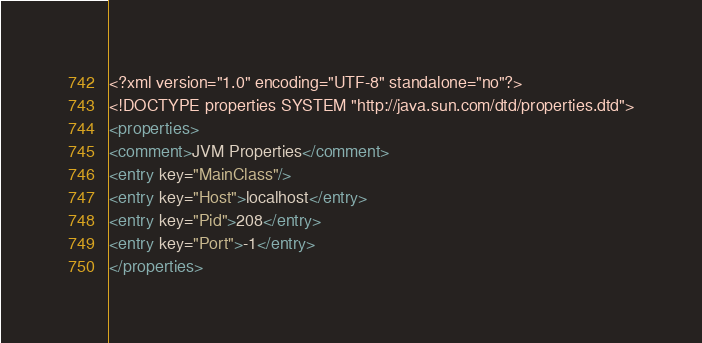<code> <loc_0><loc_0><loc_500><loc_500><_XML_><?xml version="1.0" encoding="UTF-8" standalone="no"?>
<!DOCTYPE properties SYSTEM "http://java.sun.com/dtd/properties.dtd">
<properties>
<comment>JVM Properties</comment>
<entry key="MainClass"/>
<entry key="Host">localhost</entry>
<entry key="Pid">208</entry>
<entry key="Port">-1</entry>
</properties>
</code> 